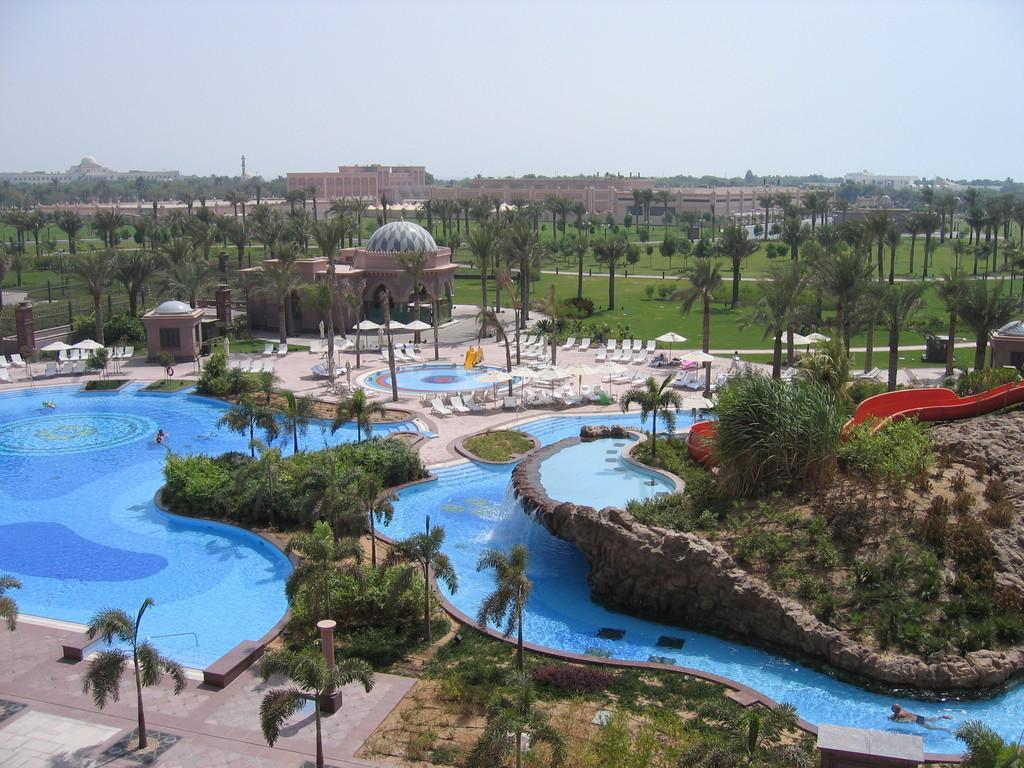Could you give a brief overview of what you see in this image? In this picture I can see swimming pools, there are sliders, there are chairs and umbrellas, there are trees, there are buildings, and in the background there is the sky. 